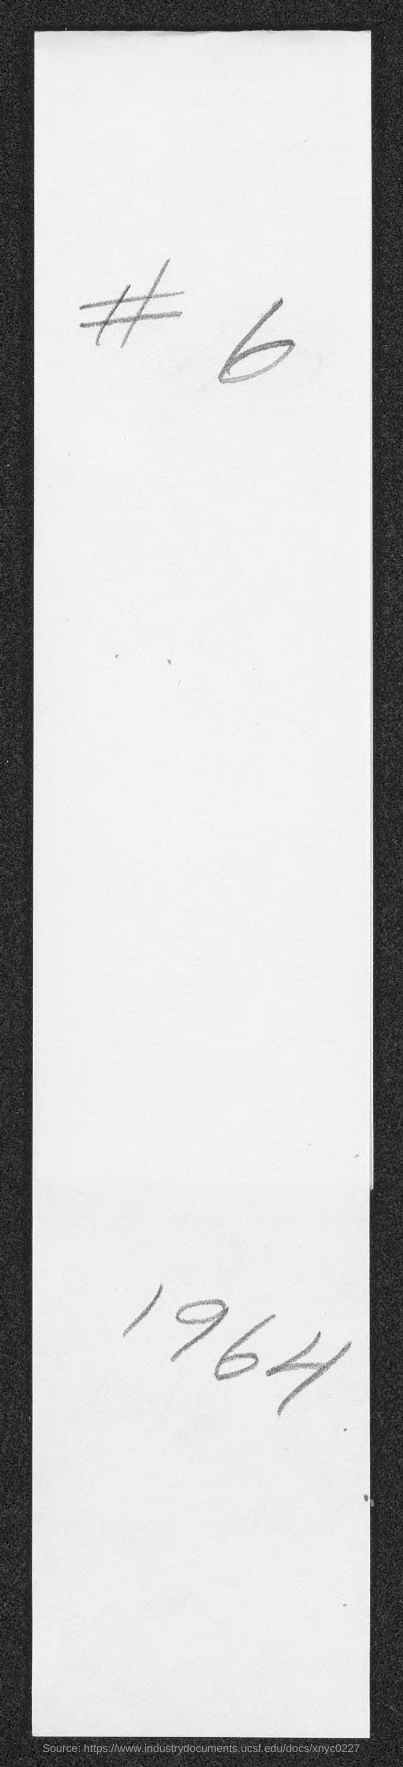What is the year mentioned in the document?
Your answer should be compact. 1964. What is the number mentioned in the document?
Offer a terse response. 6. Which symbol is in the document?
Offer a very short reply. #. 